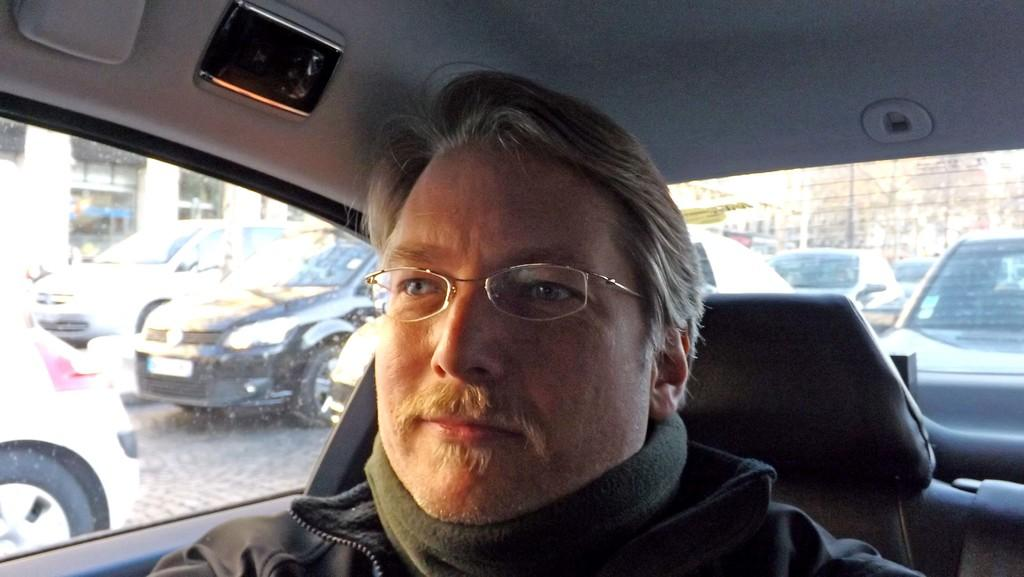Who is present in the image? There is a man in the image. What is the man wearing on his face? The man is wearing spectacles. What type of clothing is the man wearing on his upper body? The man is wearing a jacket. What is the man's facial expression in the image? The man is smiling. Where is the man located in the image? The man is sitting inside a car. What can be seen from the car window? Cars on the road, buildings with windows, and a fence are visible from the car window. What type of agreement is the man signing in the image? There is no agreement present in the image; the man is sitting inside a car and smiling. 